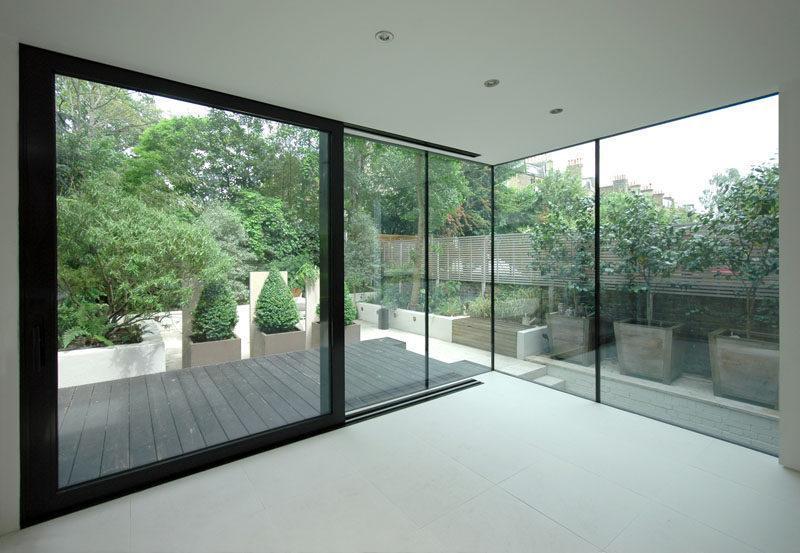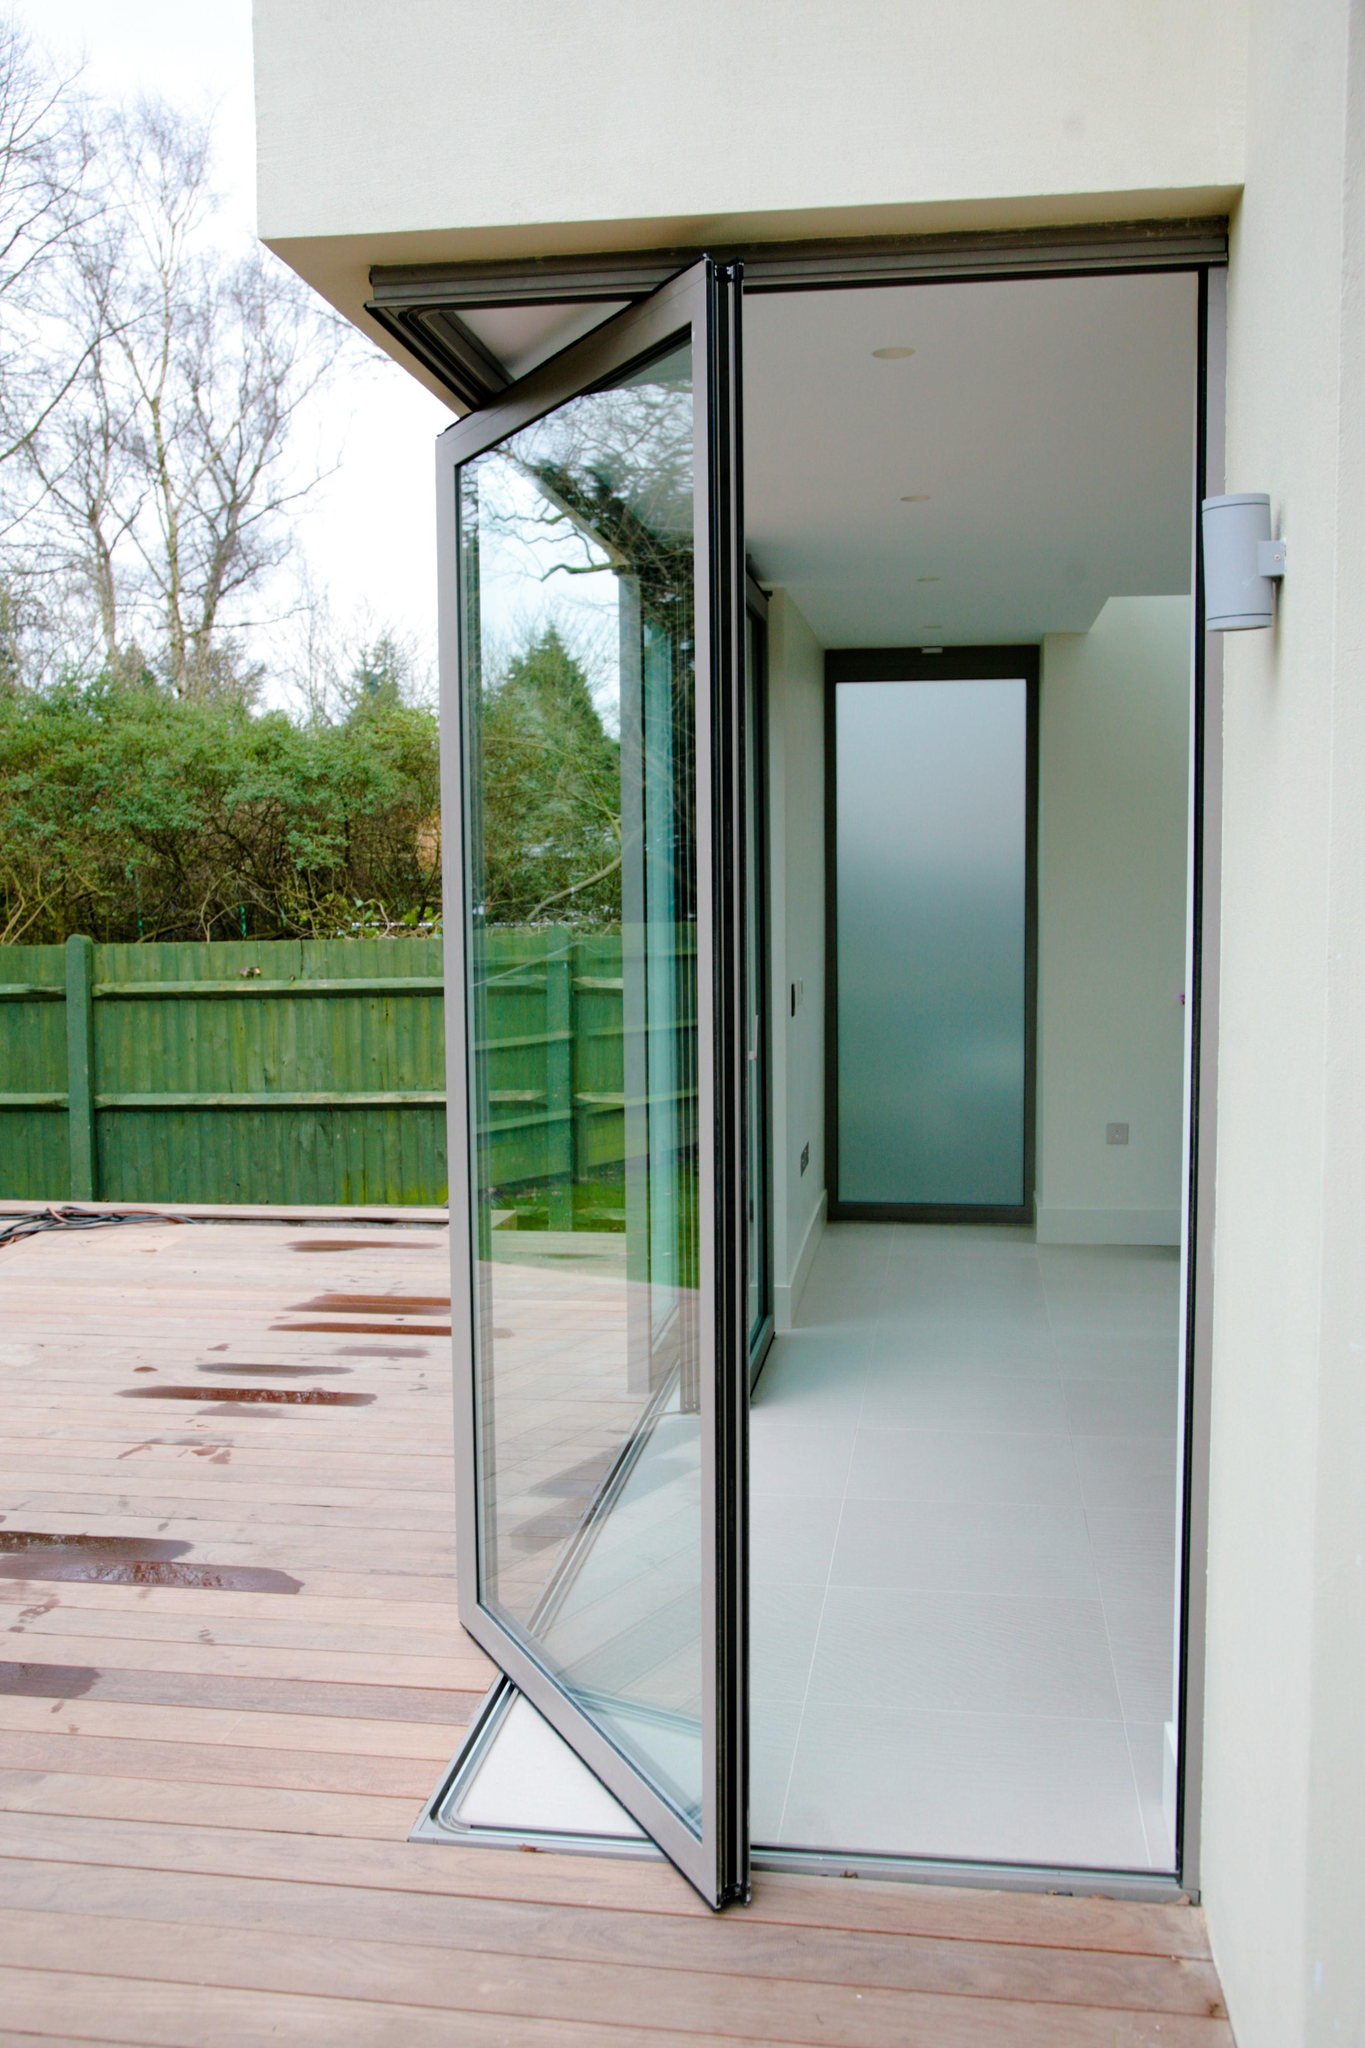The first image is the image on the left, the second image is the image on the right. Given the left and right images, does the statement "The doors are open in the right image." hold true? Answer yes or no. Yes. 